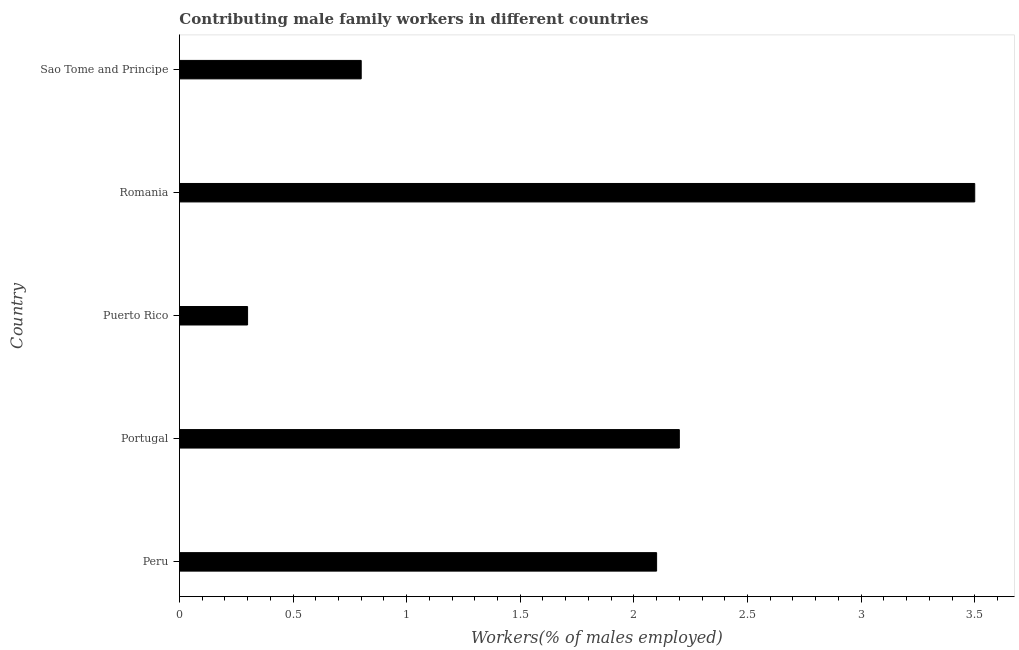Does the graph contain grids?
Offer a terse response. No. What is the title of the graph?
Offer a very short reply. Contributing male family workers in different countries. What is the label or title of the X-axis?
Keep it short and to the point. Workers(% of males employed). What is the contributing male family workers in Peru?
Your answer should be compact. 2.1. Across all countries, what is the minimum contributing male family workers?
Your answer should be compact. 0.3. In which country was the contributing male family workers maximum?
Give a very brief answer. Romania. In which country was the contributing male family workers minimum?
Make the answer very short. Puerto Rico. What is the sum of the contributing male family workers?
Your answer should be very brief. 8.9. What is the difference between the contributing male family workers in Peru and Puerto Rico?
Offer a very short reply. 1.8. What is the average contributing male family workers per country?
Offer a terse response. 1.78. What is the median contributing male family workers?
Your response must be concise. 2.1. In how many countries, is the contributing male family workers greater than 1.5 %?
Offer a very short reply. 3. What is the ratio of the contributing male family workers in Portugal to that in Sao Tome and Principe?
Give a very brief answer. 2.75. What is the difference between the highest and the lowest contributing male family workers?
Give a very brief answer. 3.2. In how many countries, is the contributing male family workers greater than the average contributing male family workers taken over all countries?
Your answer should be very brief. 3. How many bars are there?
Provide a succinct answer. 5. Are all the bars in the graph horizontal?
Offer a very short reply. Yes. How many countries are there in the graph?
Make the answer very short. 5. What is the difference between two consecutive major ticks on the X-axis?
Ensure brevity in your answer.  0.5. Are the values on the major ticks of X-axis written in scientific E-notation?
Keep it short and to the point. No. What is the Workers(% of males employed) in Peru?
Provide a succinct answer. 2.1. What is the Workers(% of males employed) in Portugal?
Keep it short and to the point. 2.2. What is the Workers(% of males employed) of Puerto Rico?
Make the answer very short. 0.3. What is the Workers(% of males employed) in Sao Tome and Principe?
Offer a very short reply. 0.8. What is the difference between the Workers(% of males employed) in Peru and Puerto Rico?
Keep it short and to the point. 1.8. What is the difference between the Workers(% of males employed) in Peru and Romania?
Offer a terse response. -1.4. What is the difference between the Workers(% of males employed) in Portugal and Puerto Rico?
Make the answer very short. 1.9. What is the difference between the Workers(% of males employed) in Portugal and Sao Tome and Principe?
Make the answer very short. 1.4. What is the difference between the Workers(% of males employed) in Puerto Rico and Romania?
Make the answer very short. -3.2. What is the difference between the Workers(% of males employed) in Puerto Rico and Sao Tome and Principe?
Give a very brief answer. -0.5. What is the ratio of the Workers(% of males employed) in Peru to that in Portugal?
Provide a short and direct response. 0.95. What is the ratio of the Workers(% of males employed) in Peru to that in Puerto Rico?
Your answer should be compact. 7. What is the ratio of the Workers(% of males employed) in Peru to that in Sao Tome and Principe?
Your answer should be very brief. 2.62. What is the ratio of the Workers(% of males employed) in Portugal to that in Puerto Rico?
Offer a very short reply. 7.33. What is the ratio of the Workers(% of males employed) in Portugal to that in Romania?
Offer a very short reply. 0.63. What is the ratio of the Workers(% of males employed) in Portugal to that in Sao Tome and Principe?
Give a very brief answer. 2.75. What is the ratio of the Workers(% of males employed) in Puerto Rico to that in Romania?
Your answer should be compact. 0.09. What is the ratio of the Workers(% of males employed) in Puerto Rico to that in Sao Tome and Principe?
Your response must be concise. 0.38. What is the ratio of the Workers(% of males employed) in Romania to that in Sao Tome and Principe?
Give a very brief answer. 4.38. 